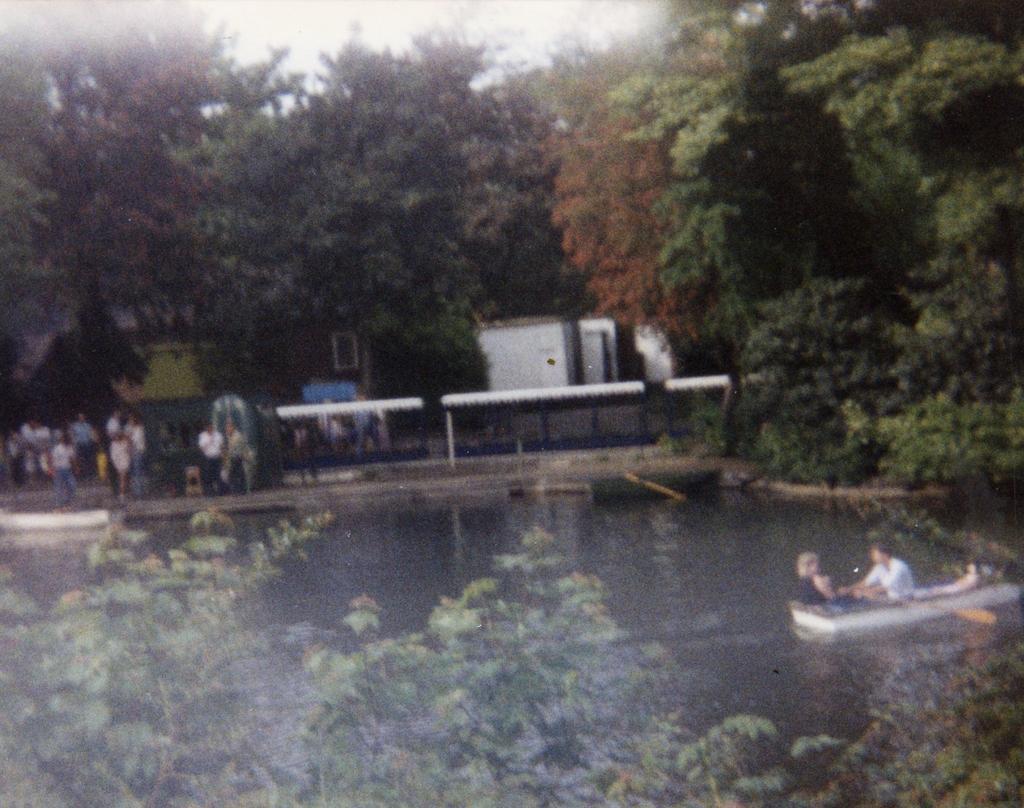In one or two sentences, can you explain what this image depicts? In this image we can see a boat on the water. There are two persons sitting in the boat. And one person is holding paddle. There are trees. In the back we can see few people. Also there are buildings. And there is a shed. 